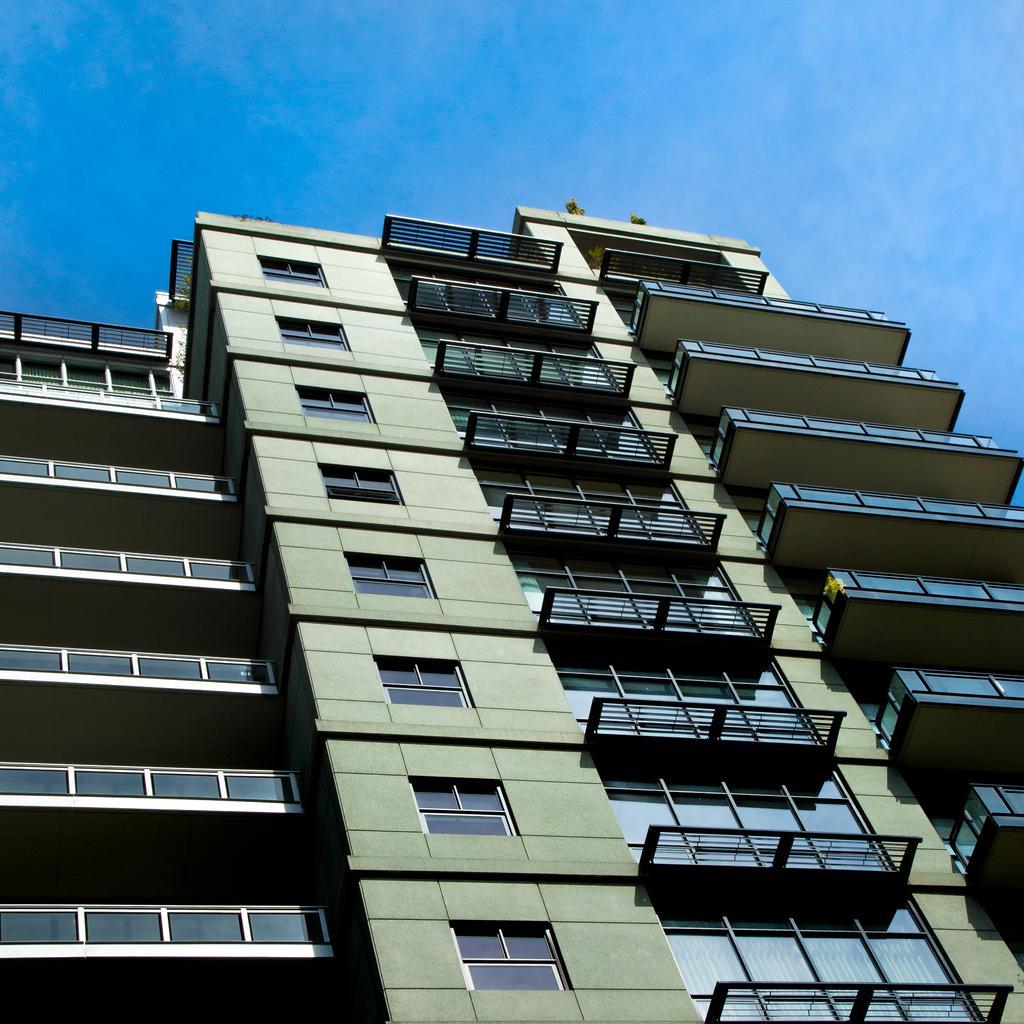In one or two sentences, can you explain what this image depicts? In this image I can see the building and at the top I can see the sky. 